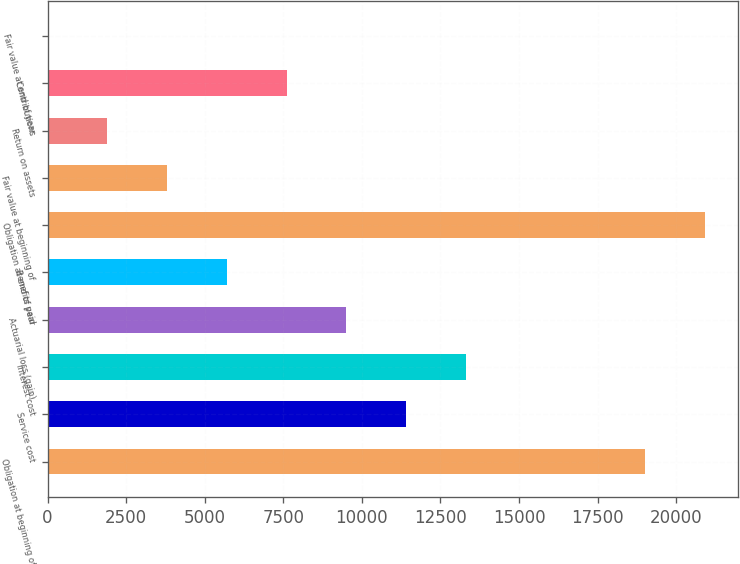Convert chart to OTSL. <chart><loc_0><loc_0><loc_500><loc_500><bar_chart><fcel>Obligation at beginning of<fcel>Service cost<fcel>Interest cost<fcel>Actuarial loss (gain)<fcel>Benefits paid<fcel>Obligation at end of year<fcel>Fair value at beginning of<fcel>Return on assets<fcel>Contributions<fcel>Fair value at end of year<nl><fcel>19008<fcel>11405.5<fcel>13306.1<fcel>9504.93<fcel>5703.71<fcel>20908.6<fcel>3803.1<fcel>1902.49<fcel>7604.32<fcel>1.88<nl></chart> 